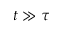<formula> <loc_0><loc_0><loc_500><loc_500>t \gg \tau</formula> 